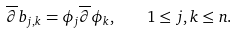Convert formula to latex. <formula><loc_0><loc_0><loc_500><loc_500>\overline { \partial } b _ { j , k } = \phi _ { j } \overline { \partial } \phi _ { k } , \quad 1 \leq j , k \leq n .</formula> 